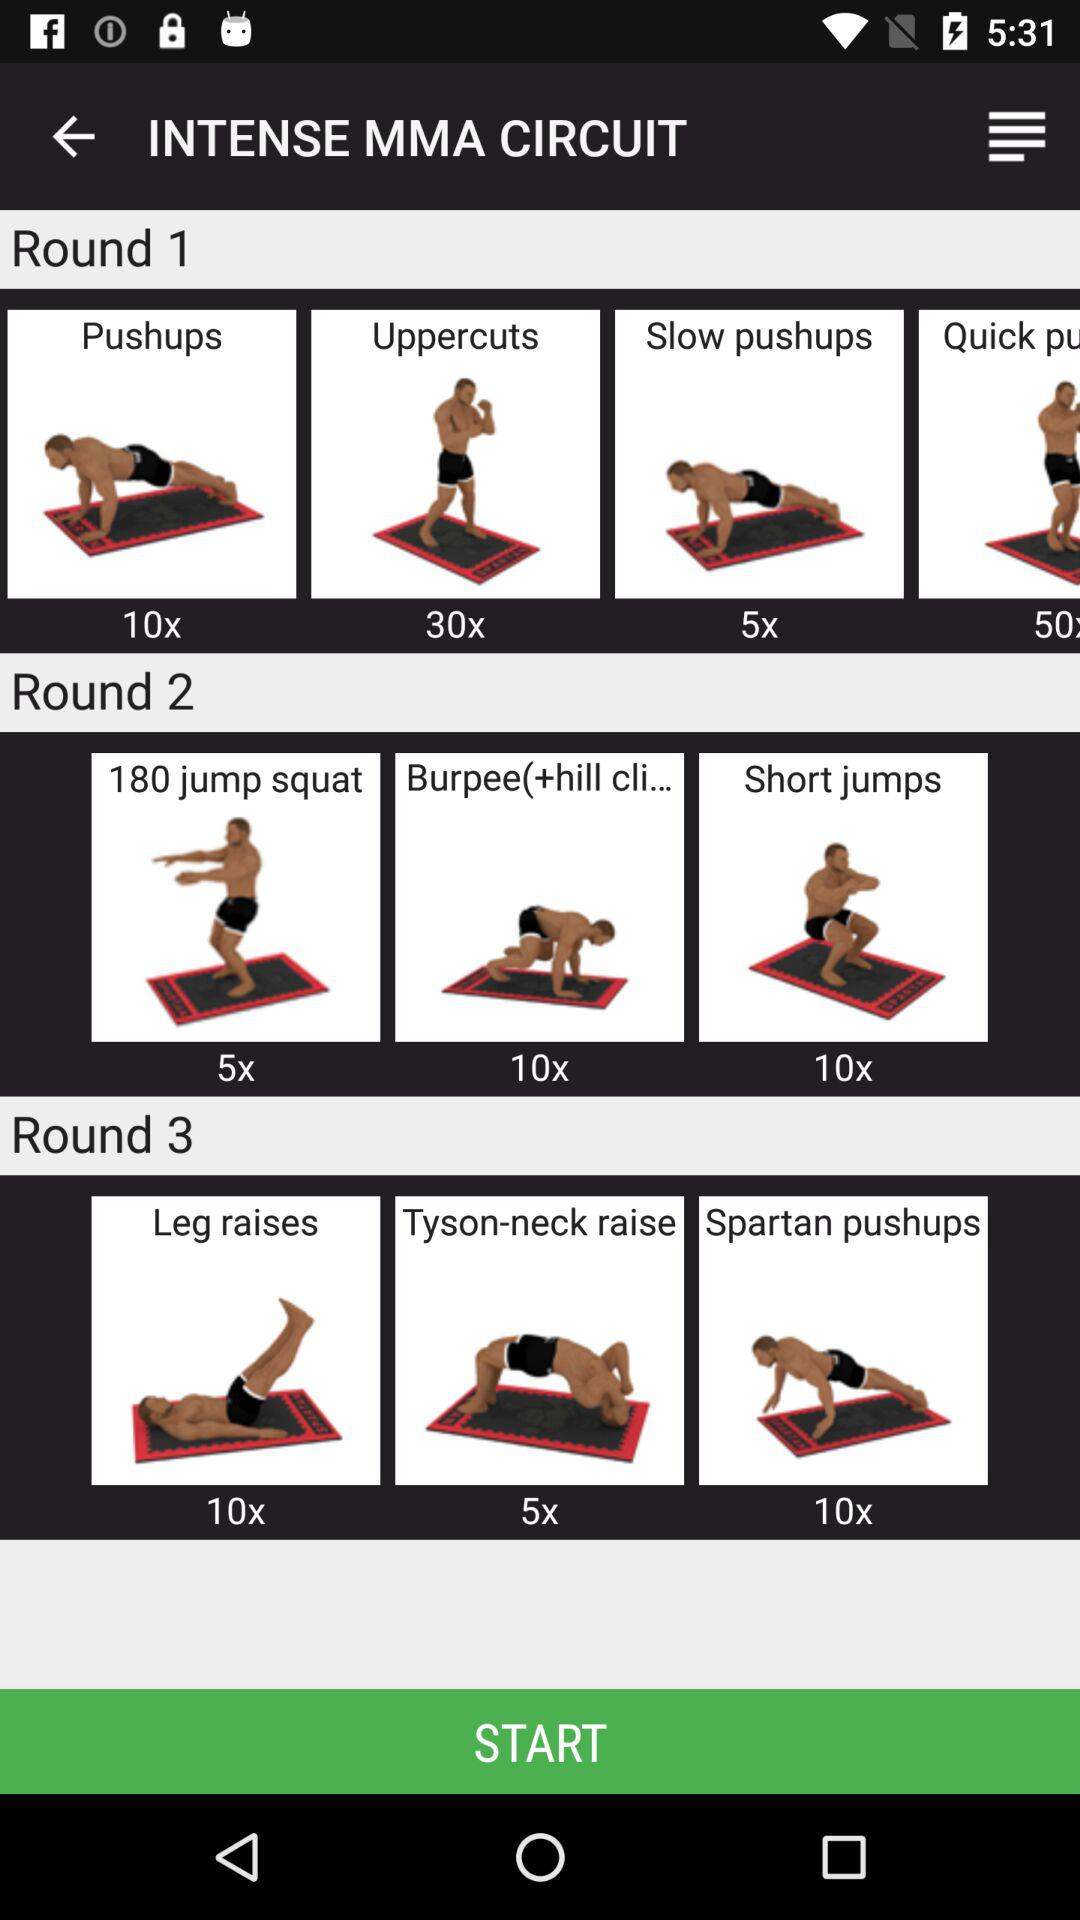How many sets are there in this workout?
Answer the question using a single word or phrase. 3 